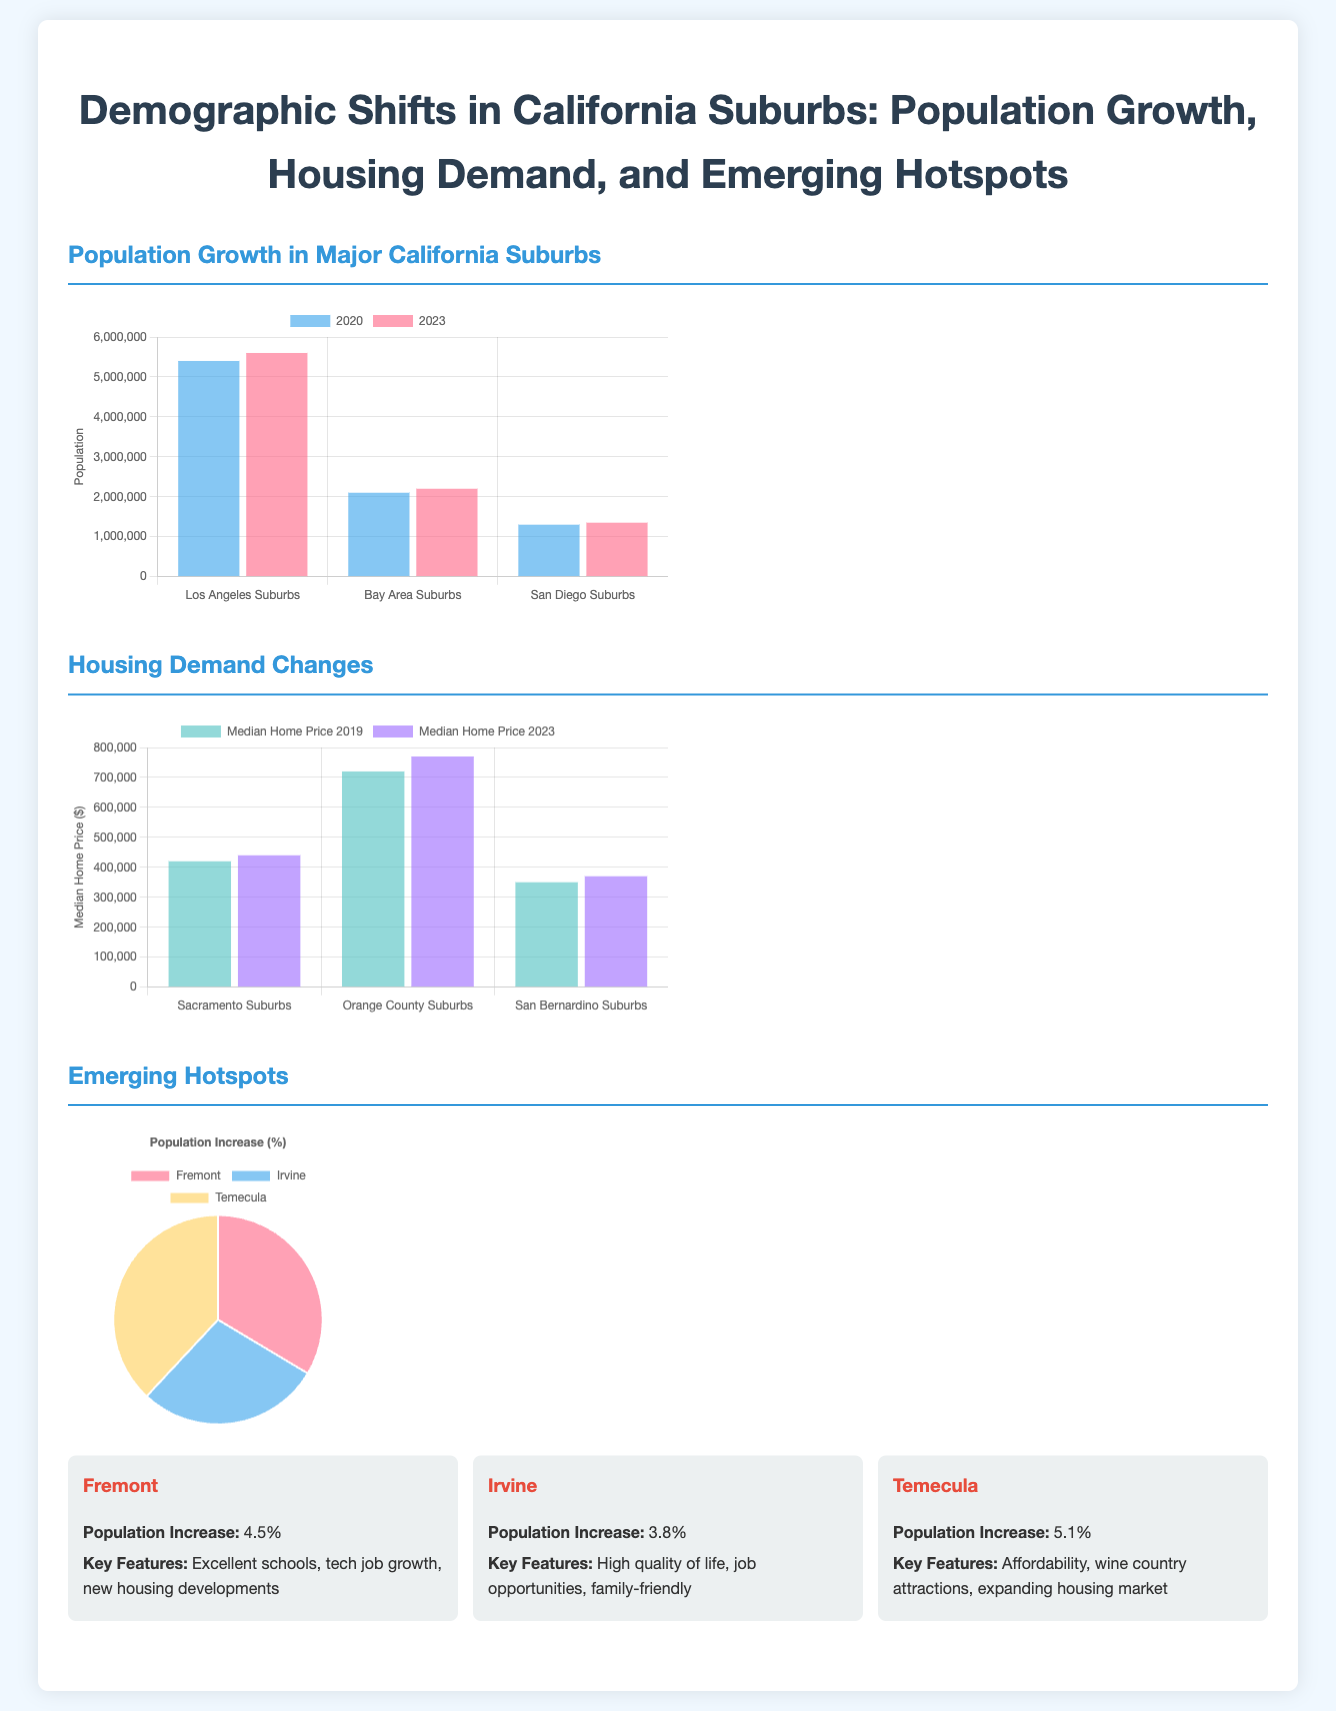What was the population of Los Angeles suburbs in 2020? The population of Los Angeles suburbs in 2020 is shown in the bar chart as 5,400,000.
Answer: 5,400,000 What is the population increase percentage for Temecula? The infographic states that Temecula had a population increase of 5.1%.
Answer: 5.1% What were the median home prices in Orange County suburbs in 2019? The median home price for Orange County suburbs in 2019 is represented in the bar chart as $720,000.
Answer: $720,000 Which suburb had the highest population increase? The infographic lists Temecula as having the highest population increase at 5.1%.
Answer: Temecula What is the median home price in Sacramento suburbs in 2023? The median home price in Sacramento suburbs for 2023 is given as $440,000 in the housing demand chart.
Answer: $440,000 How many suburbs were shown for population growth comparison? The document compares three suburbs: Los Angeles, Bay Area, and San Diego.
Answer: Three Which city has key features related to tech job growth? The characteristics mention Fremont as having excellent schools and tech job growth.
Answer: Fremont What type of chart is used to show population increase among emerging hotspots? A pie chart is used to illustrate the percentage increase in population for emerging hotspots.
Answer: Pie chart 